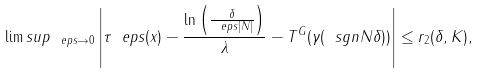Convert formula to latex. <formula><loc_0><loc_0><loc_500><loc_500>\lim s u p _ { \ e p s \to 0 } \left | \tau _ { \ } e p s ( x ) - \frac { \ln \left ( \frac { \delta } { \ e p s | N | } \right ) } { \lambda } - T ^ { G } ( \gamma ( \ s g n N \delta ) ) \right | \leq r _ { 2 } ( \delta , K ) ,</formula> 